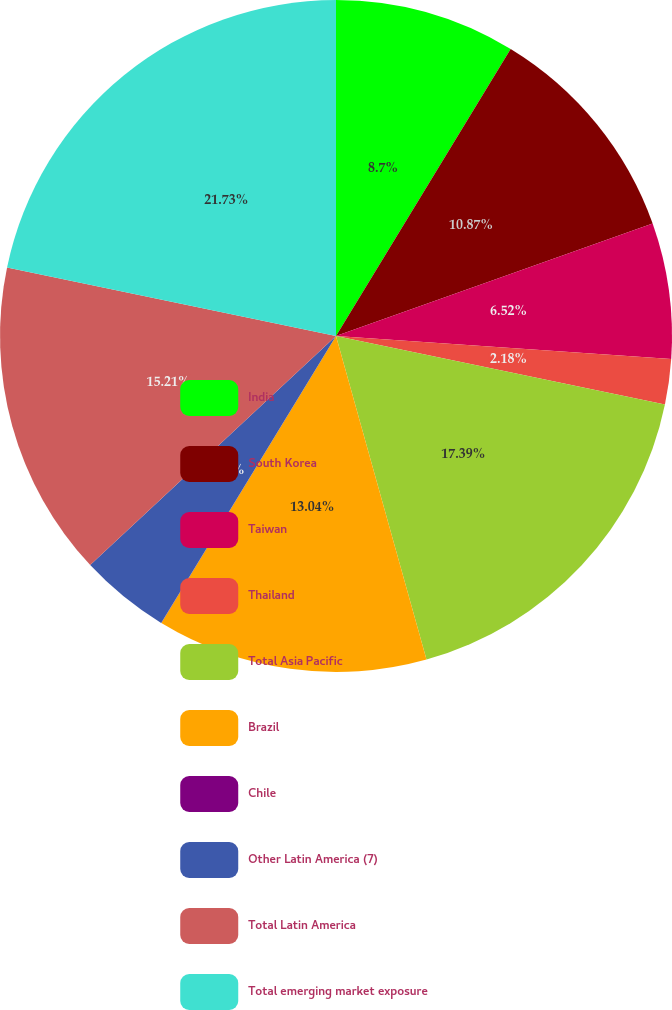Convert chart to OTSL. <chart><loc_0><loc_0><loc_500><loc_500><pie_chart><fcel>India<fcel>South Korea<fcel>Taiwan<fcel>Thailand<fcel>Total Asia Pacific<fcel>Brazil<fcel>Chile<fcel>Other Latin America (7)<fcel>Total Latin America<fcel>Total emerging market exposure<nl><fcel>8.7%<fcel>10.87%<fcel>6.52%<fcel>2.18%<fcel>17.39%<fcel>13.04%<fcel>0.01%<fcel>4.35%<fcel>15.21%<fcel>21.73%<nl></chart> 